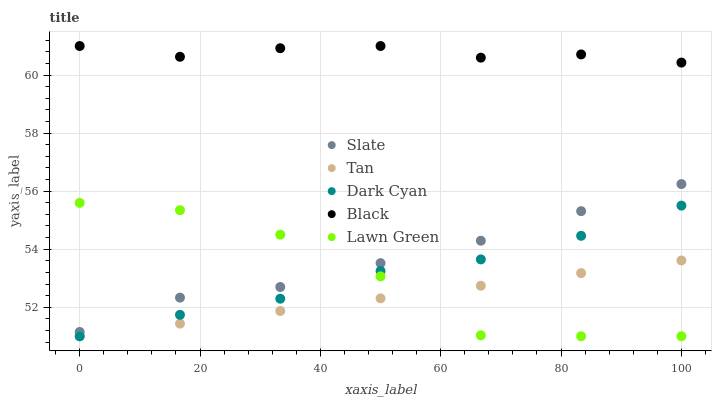Does Tan have the minimum area under the curve?
Answer yes or no. Yes. Does Black have the maximum area under the curve?
Answer yes or no. Yes. Does Lawn Green have the minimum area under the curve?
Answer yes or no. No. Does Lawn Green have the maximum area under the curve?
Answer yes or no. No. Is Tan the smoothest?
Answer yes or no. Yes. Is Lawn Green the roughest?
Answer yes or no. Yes. Is Slate the smoothest?
Answer yes or no. No. Is Slate the roughest?
Answer yes or no. No. Does Dark Cyan have the lowest value?
Answer yes or no. Yes. Does Slate have the lowest value?
Answer yes or no. No. Does Black have the highest value?
Answer yes or no. Yes. Does Lawn Green have the highest value?
Answer yes or no. No. Is Dark Cyan less than Black?
Answer yes or no. Yes. Is Slate greater than Tan?
Answer yes or no. Yes. Does Lawn Green intersect Dark Cyan?
Answer yes or no. Yes. Is Lawn Green less than Dark Cyan?
Answer yes or no. No. Is Lawn Green greater than Dark Cyan?
Answer yes or no. No. Does Dark Cyan intersect Black?
Answer yes or no. No. 